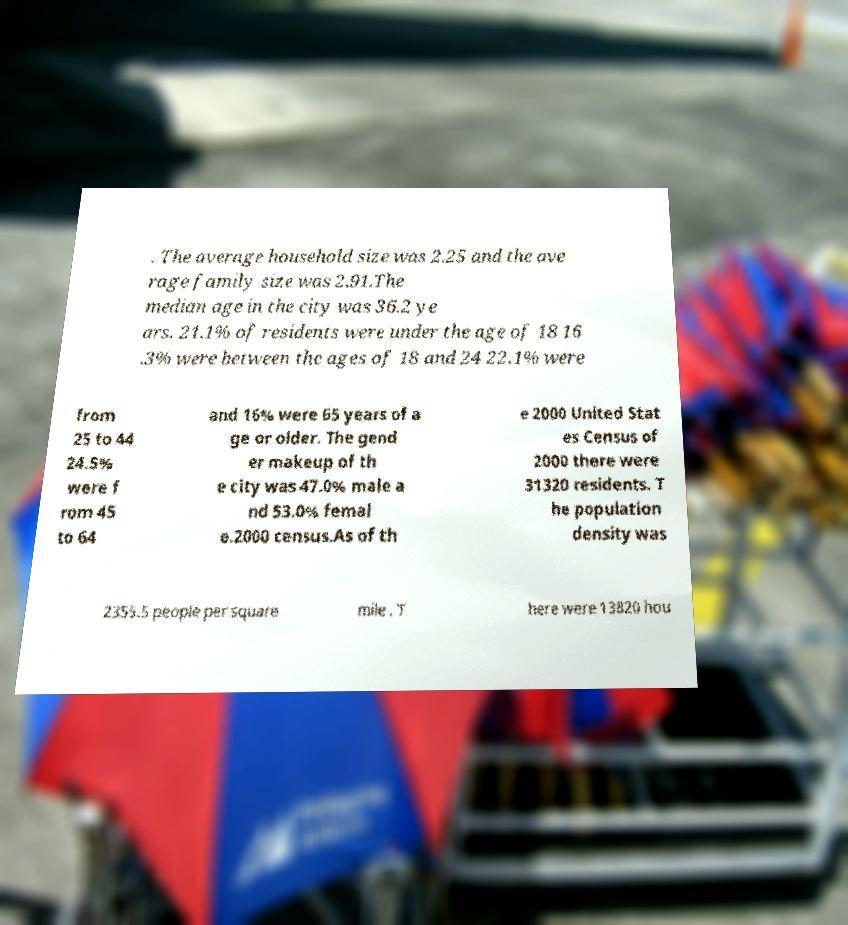There's text embedded in this image that I need extracted. Can you transcribe it verbatim? . The average household size was 2.25 and the ave rage family size was 2.91.The median age in the city was 36.2 ye ars. 21.1% of residents were under the age of 18 16 .3% were between the ages of 18 and 24 22.1% were from 25 to 44 24.5% were f rom 45 to 64 and 16% were 65 years of a ge or older. The gend er makeup of th e city was 47.0% male a nd 53.0% femal e.2000 census.As of th e 2000 United Stat es Census of 2000 there were 31320 residents. T he population density was 2355.5 people per square mile . T here were 13820 hou 